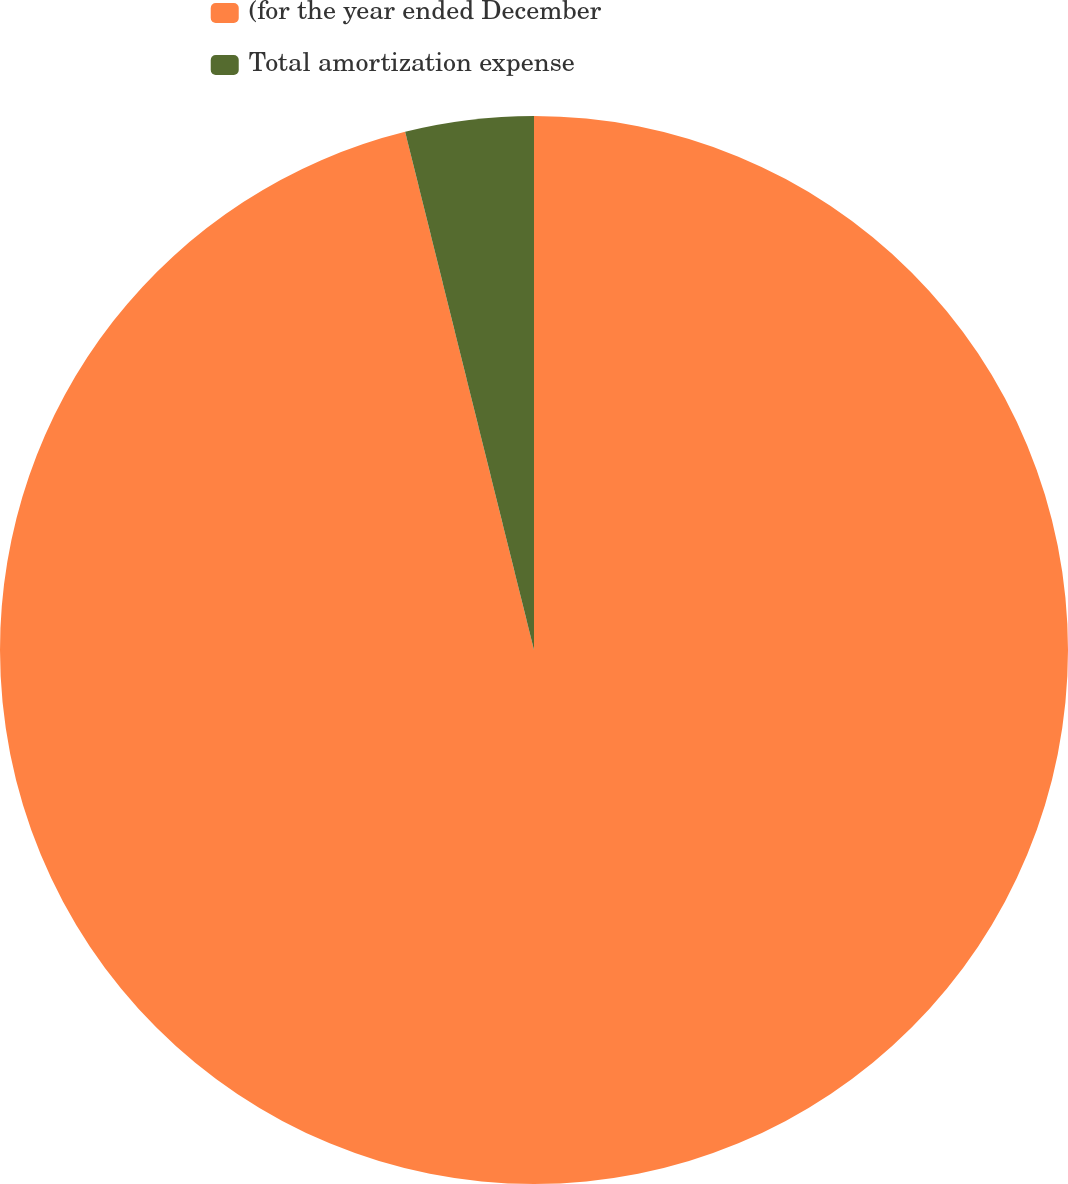Convert chart. <chart><loc_0><loc_0><loc_500><loc_500><pie_chart><fcel>(for the year ended December<fcel>Total amortization expense<nl><fcel>96.12%<fcel>3.88%<nl></chart> 